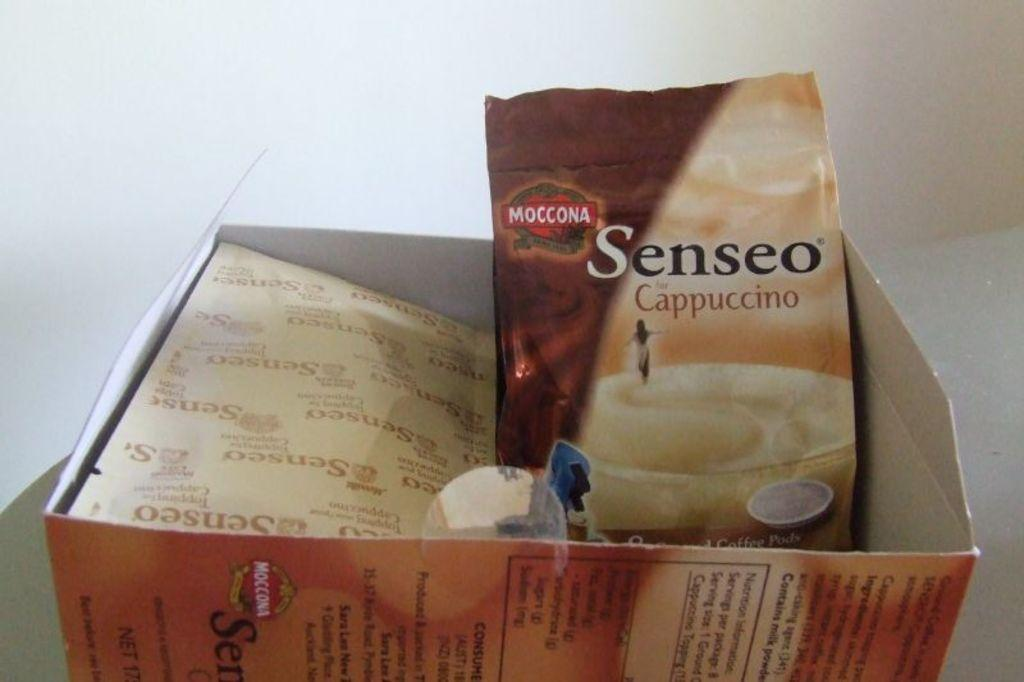<image>
Provide a brief description of the given image. A box containing a bag of Senseo Cappucino 